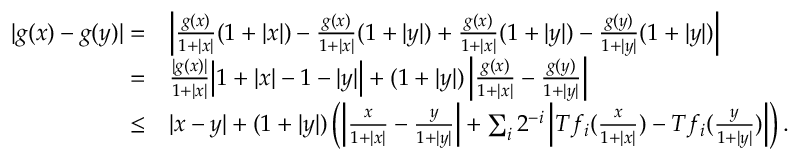Convert formula to latex. <formula><loc_0><loc_0><loc_500><loc_500>\begin{array} { r l } { | g ( x ) - g ( y ) | = } & { \left | \frac { g ( x ) } { 1 + | x | } ( 1 + | x | ) - \frac { g ( x ) } { 1 + | x | } ( 1 + | y | ) + \frac { g ( x ) } { 1 + | x | } ( 1 + | y | ) - \frac { g ( y ) } { 1 + | y | } ( 1 + | y | ) \right | } \\ { = } & { \frac { | g ( x ) | } { 1 + | x | } \left | 1 + | x | - 1 - | y | \right | + ( 1 + | y | ) \left | \frac { g ( x ) } { 1 + | x | } - \frac { g ( y ) } { 1 + | y | } \right | } \\ { \leq } & { | x - y | + ( 1 + | y | ) \left ( \left | \frac { x } { 1 + | x | } - \frac { y } { 1 + | y | } \right | + \sum _ { i } 2 ^ { - i } \left | T f _ { i } ( \frac { x } { 1 + | x | } ) - T f _ { i } ( \frac { y } { 1 + | y | } ) \right | \right ) . } \end{array}</formula> 